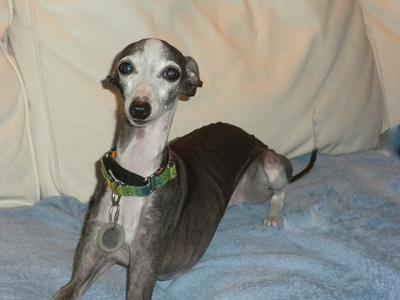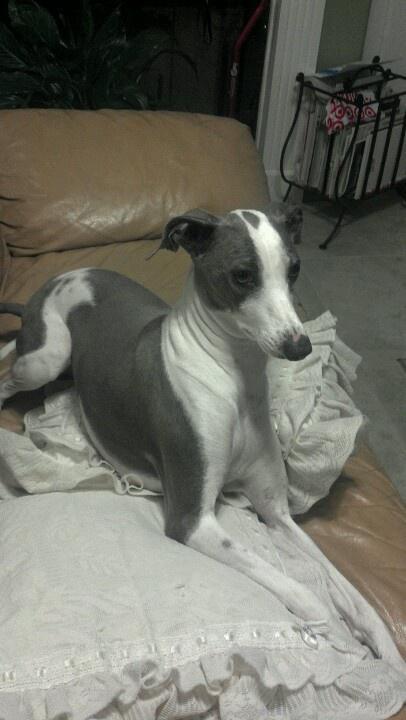The first image is the image on the left, the second image is the image on the right. For the images shown, is this caption "At least one of the dog is wearing a collar." true? Answer yes or no. Yes. The first image is the image on the left, the second image is the image on the right. Considering the images on both sides, is "One image shows a dog sitting upright, and the other shows at least one dog standing on all fours." valid? Answer yes or no. No. 